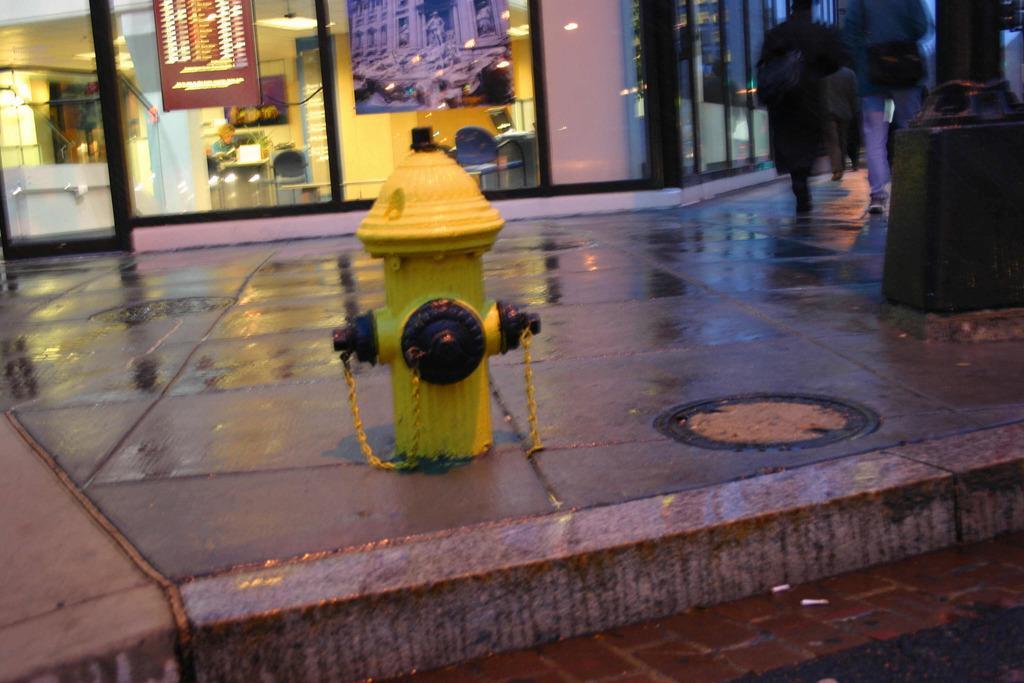Please provide a concise description of this image. In this image in the foreground there is a fire hydrant. In the sidewalk few people are walking. In the background there is a building. Inside the building there are chairs, tables, paintings. 